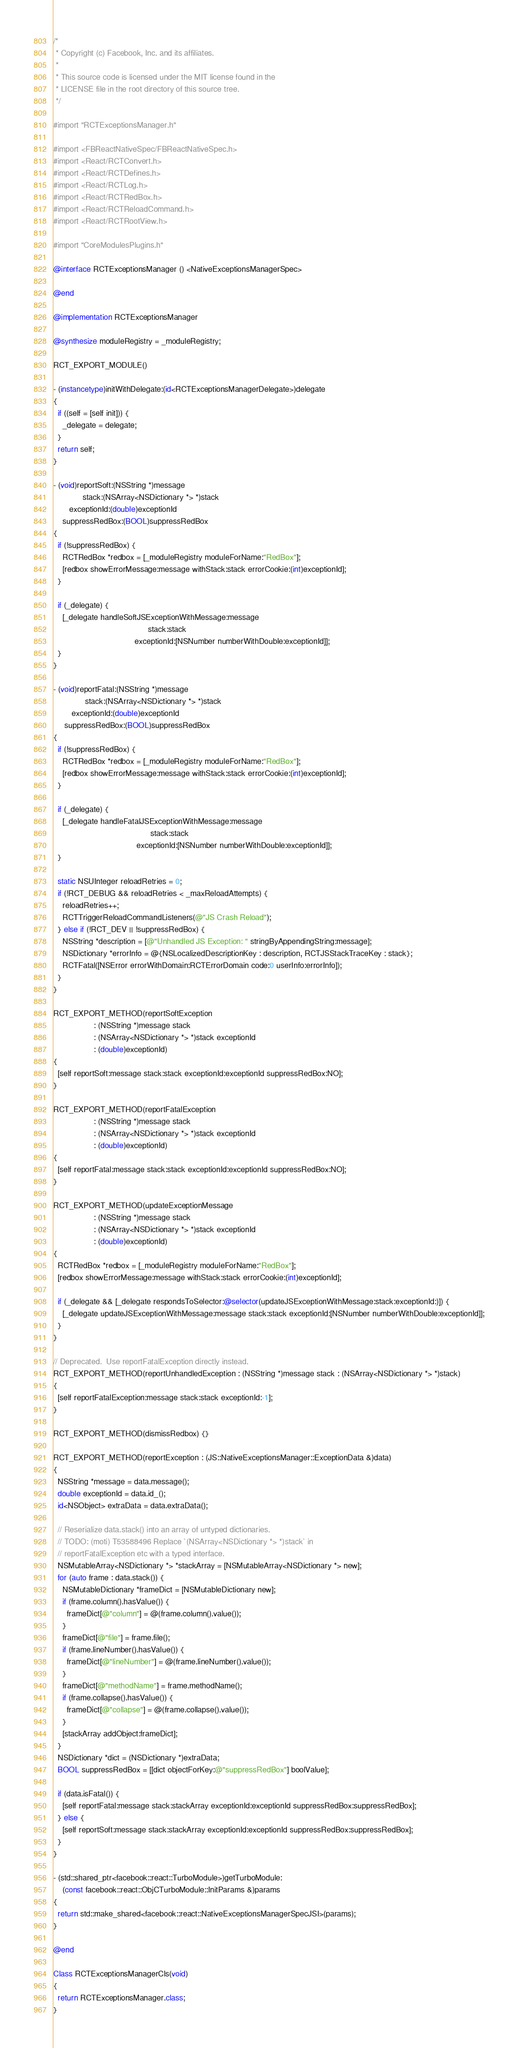<code> <loc_0><loc_0><loc_500><loc_500><_ObjectiveC_>/*
 * Copyright (c) Facebook, Inc. and its affiliates.
 *
 * This source code is licensed under the MIT license found in the
 * LICENSE file in the root directory of this source tree.
 */

#import "RCTExceptionsManager.h"

#import <FBReactNativeSpec/FBReactNativeSpec.h>
#import <React/RCTConvert.h>
#import <React/RCTDefines.h>
#import <React/RCTLog.h>
#import <React/RCTRedBox.h>
#import <React/RCTReloadCommand.h>
#import <React/RCTRootView.h>

#import "CoreModulesPlugins.h"

@interface RCTExceptionsManager () <NativeExceptionsManagerSpec>

@end

@implementation RCTExceptionsManager

@synthesize moduleRegistry = _moduleRegistry;

RCT_EXPORT_MODULE()

- (instancetype)initWithDelegate:(id<RCTExceptionsManagerDelegate>)delegate
{
  if ((self = [self init])) {
    _delegate = delegate;
  }
  return self;
}

- (void)reportSoft:(NSString *)message
             stack:(NSArray<NSDictionary *> *)stack
       exceptionId:(double)exceptionId
    suppressRedBox:(BOOL)suppressRedBox
{
  if (!suppressRedBox) {
    RCTRedBox *redbox = [_moduleRegistry moduleForName:"RedBox"];
    [redbox showErrorMessage:message withStack:stack errorCookie:(int)exceptionId];
  }

  if (_delegate) {
    [_delegate handleSoftJSExceptionWithMessage:message
                                          stack:stack
                                    exceptionId:[NSNumber numberWithDouble:exceptionId]];
  }
}

- (void)reportFatal:(NSString *)message
              stack:(NSArray<NSDictionary *> *)stack
        exceptionId:(double)exceptionId
     suppressRedBox:(BOOL)suppressRedBox
{
  if (!suppressRedBox) {
    RCTRedBox *redbox = [_moduleRegistry moduleForName:"RedBox"];
    [redbox showErrorMessage:message withStack:stack errorCookie:(int)exceptionId];
  }

  if (_delegate) {
    [_delegate handleFatalJSExceptionWithMessage:message
                                           stack:stack
                                     exceptionId:[NSNumber numberWithDouble:exceptionId]];
  }

  static NSUInteger reloadRetries = 0;
  if (!RCT_DEBUG && reloadRetries < _maxReloadAttempts) {
    reloadRetries++;
    RCTTriggerReloadCommandListeners(@"JS Crash Reload");
  } else if (!RCT_DEV || !suppressRedBox) {
    NSString *description = [@"Unhandled JS Exception: " stringByAppendingString:message];
    NSDictionary *errorInfo = @{NSLocalizedDescriptionKey : description, RCTJSStackTraceKey : stack};
    RCTFatal([NSError errorWithDomain:RCTErrorDomain code:0 userInfo:errorInfo]);
  }
}

RCT_EXPORT_METHOD(reportSoftException
                  : (NSString *)message stack
                  : (NSArray<NSDictionary *> *)stack exceptionId
                  : (double)exceptionId)
{
  [self reportSoft:message stack:stack exceptionId:exceptionId suppressRedBox:NO];
}

RCT_EXPORT_METHOD(reportFatalException
                  : (NSString *)message stack
                  : (NSArray<NSDictionary *> *)stack exceptionId
                  : (double)exceptionId)
{
  [self reportFatal:message stack:stack exceptionId:exceptionId suppressRedBox:NO];
}

RCT_EXPORT_METHOD(updateExceptionMessage
                  : (NSString *)message stack
                  : (NSArray<NSDictionary *> *)stack exceptionId
                  : (double)exceptionId)
{
  RCTRedBox *redbox = [_moduleRegistry moduleForName:"RedBox"];
  [redbox showErrorMessage:message withStack:stack errorCookie:(int)exceptionId];

  if (_delegate && [_delegate respondsToSelector:@selector(updateJSExceptionWithMessage:stack:exceptionId:)]) {
    [_delegate updateJSExceptionWithMessage:message stack:stack exceptionId:[NSNumber numberWithDouble:exceptionId]];
  }
}

// Deprecated.  Use reportFatalException directly instead.
RCT_EXPORT_METHOD(reportUnhandledException : (NSString *)message stack : (NSArray<NSDictionary *> *)stack)
{
  [self reportFatalException:message stack:stack exceptionId:-1];
}

RCT_EXPORT_METHOD(dismissRedbox) {}

RCT_EXPORT_METHOD(reportException : (JS::NativeExceptionsManager::ExceptionData &)data)
{
  NSString *message = data.message();
  double exceptionId = data.id_();
  id<NSObject> extraData = data.extraData();

  // Reserialize data.stack() into an array of untyped dictionaries.
  // TODO: (moti) T53588496 Replace `(NSArray<NSDictionary *> *)stack` in
  // reportFatalException etc with a typed interface.
  NSMutableArray<NSDictionary *> *stackArray = [NSMutableArray<NSDictionary *> new];
  for (auto frame : data.stack()) {
    NSMutableDictionary *frameDict = [NSMutableDictionary new];
    if (frame.column().hasValue()) {
      frameDict[@"column"] = @(frame.column().value());
    }
    frameDict[@"file"] = frame.file();
    if (frame.lineNumber().hasValue()) {
      frameDict[@"lineNumber"] = @(frame.lineNumber().value());
    }
    frameDict[@"methodName"] = frame.methodName();
    if (frame.collapse().hasValue()) {
      frameDict[@"collapse"] = @(frame.collapse().value());
    }
    [stackArray addObject:frameDict];
  }
  NSDictionary *dict = (NSDictionary *)extraData;
  BOOL suppressRedBox = [[dict objectForKey:@"suppressRedBox"] boolValue];

  if (data.isFatal()) {
    [self reportFatal:message stack:stackArray exceptionId:exceptionId suppressRedBox:suppressRedBox];
  } else {
    [self reportSoft:message stack:stackArray exceptionId:exceptionId suppressRedBox:suppressRedBox];
  }
}

- (std::shared_ptr<facebook::react::TurboModule>)getTurboModule:
    (const facebook::react::ObjCTurboModule::InitParams &)params
{
  return std::make_shared<facebook::react::NativeExceptionsManagerSpecJSI>(params);
}

@end

Class RCTExceptionsManagerCls(void)
{
  return RCTExceptionsManager.class;
}
</code> 